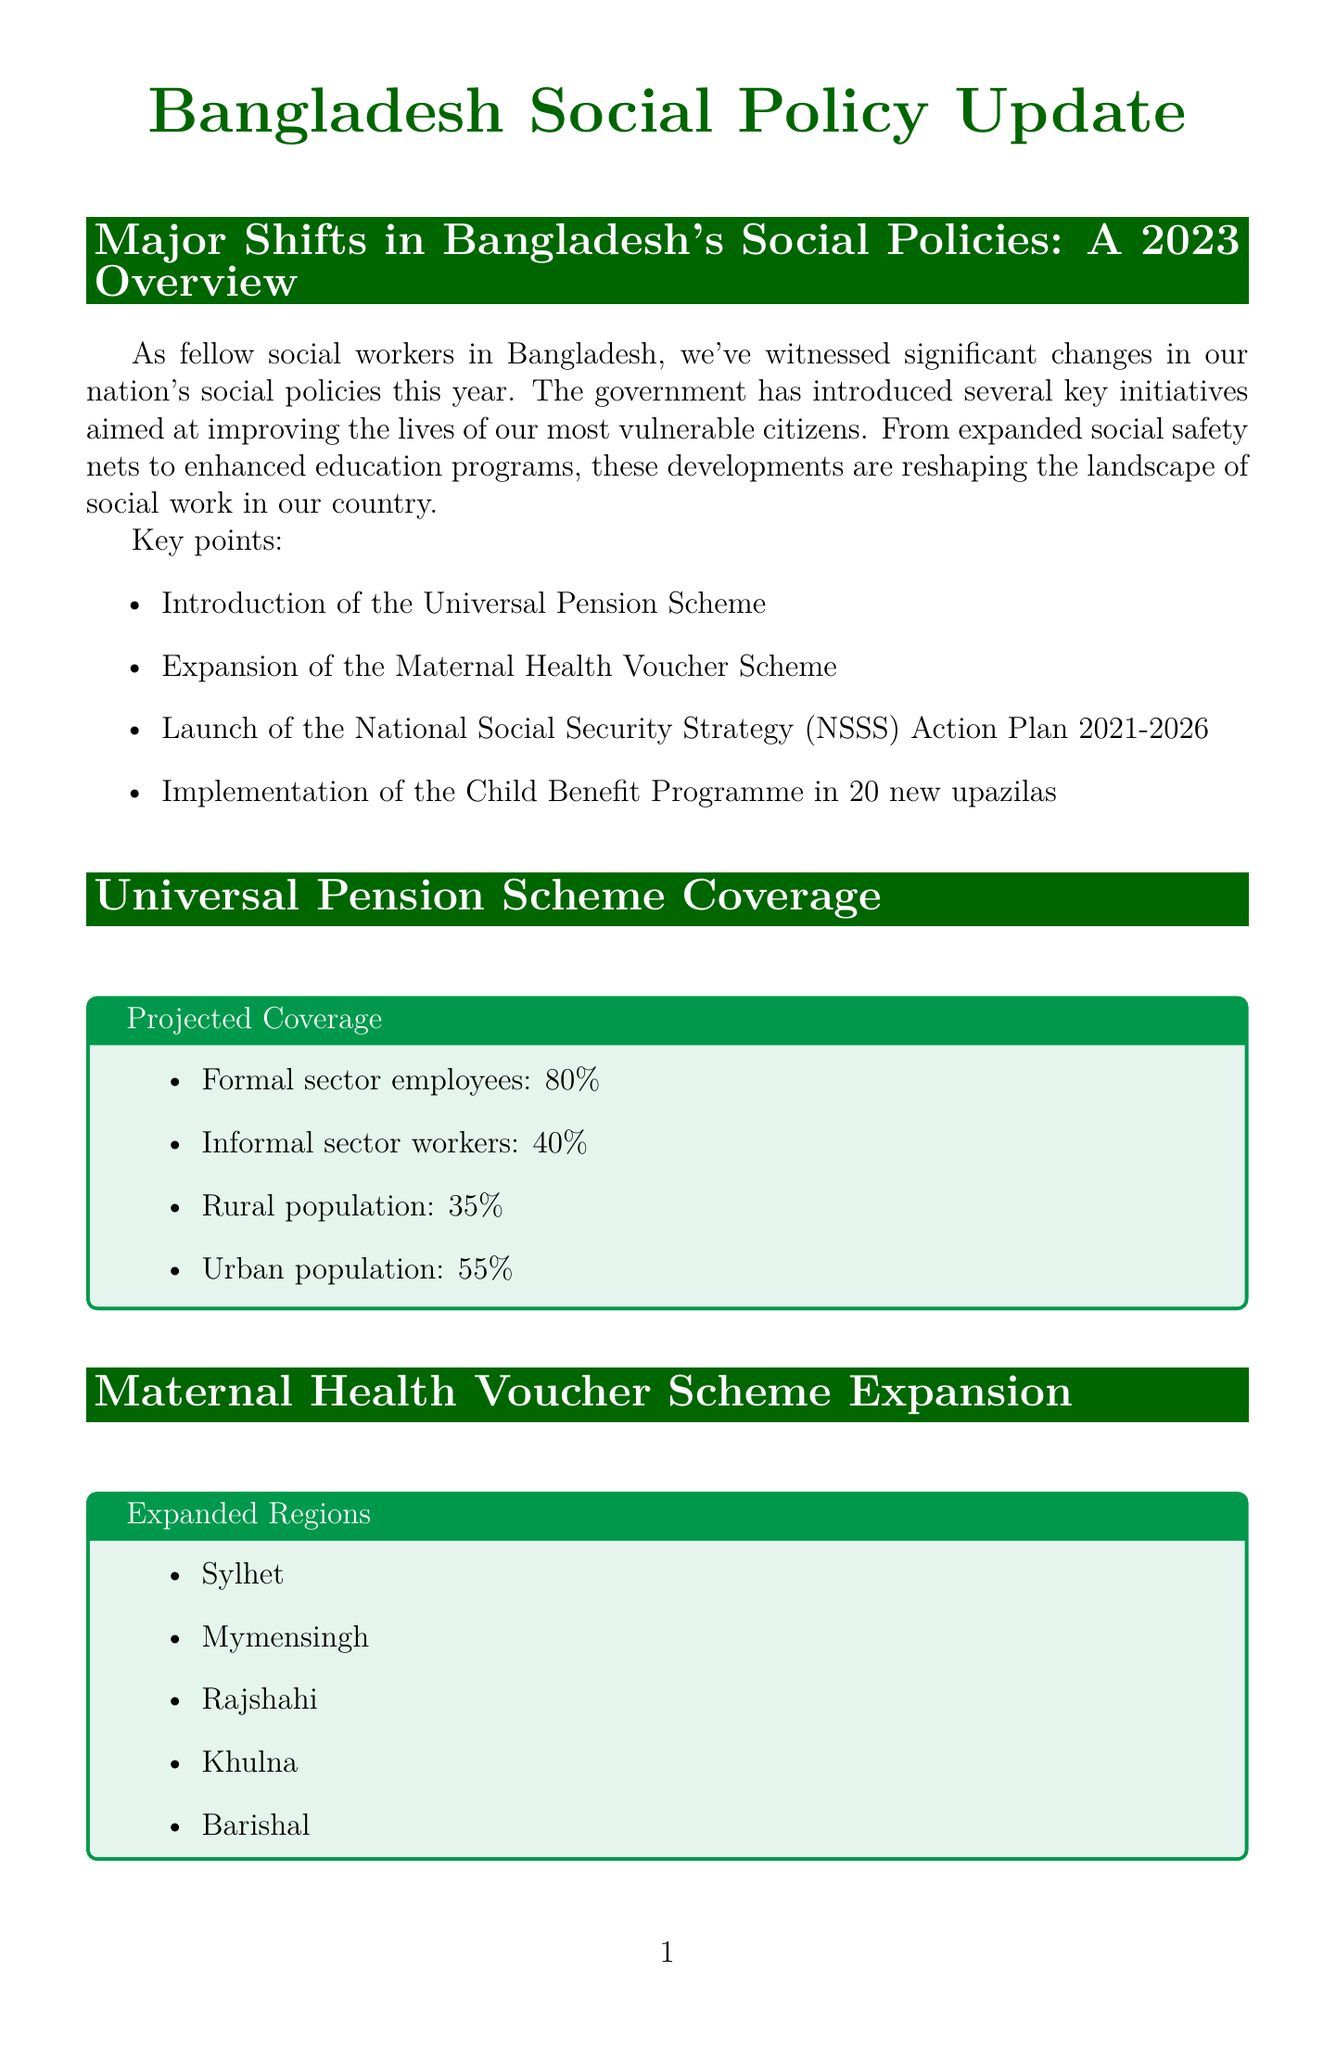What is the title of the newsletter? The title of the newsletter is stated at the top of the document.
Answer: Bangladesh Social Policy Update What new scheme is introduced for pension? The content outlines a new initiative regarding pensions introduced by the government.
Answer: Universal Pension Scheme How many new upazilas are included in the Child Benefit Programme? The article mentions the number of upazilas for the Child Benefit Programme explicitly.
Answer: 20 What percentage of formal sector employees will be covered by the Universal Pension Scheme? The infographic provides specific coverage percentages for different groups.
Answer: 80% Which regions are included in the expansion of the Maternal Health Voucher Scheme? The document lists specific districts where the scheme has been expanded.
Answer: Sylhet, Mymensingh, Rajshahi, Khulna, Barishal What is the focus area of the NSSS Action Plan? The sidebar mentions key areas of focus in the NSSS Action Plan.
Answer: Poverty reduction Who is quoted in the expert opinion section? The document includes an expert opinion and cites the individual's name.
Answer: Dr. Fahmida Khatun When will the National Social Work Conference take place? The upcoming events section provides specific dates for the conference.
Answer: September 15-17, 2023 What is the purpose of the workshop on October 5, 2023? The document describes the workshop's aim in the upcoming events section.
Answer: Capacity building for social workers 